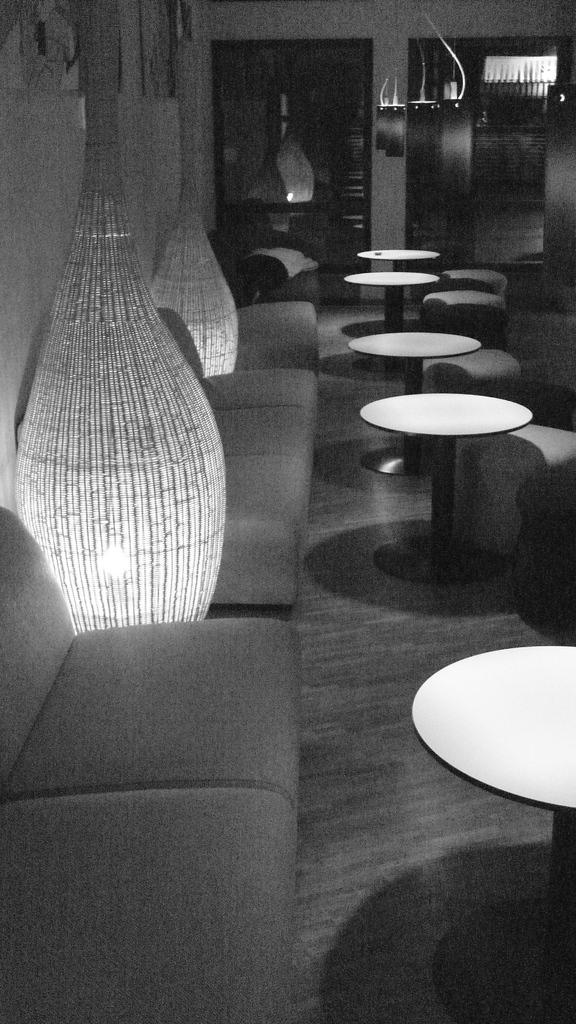What type of furniture is present in the image? There are sofas and tables in the image. What can be seen on the walls in the image? There is a wall visible in the image. What is on the floor in the image? There are objects on the floor in the image. What is the color scheme of the image? The image is black and white in color. What grade did the person receive on their journey in the image? There is no journey or grade present in the image; it features furniture and a wall. What type of gardening tool is visible in the image? There is no gardening tool, such as a spade, present in the image. 